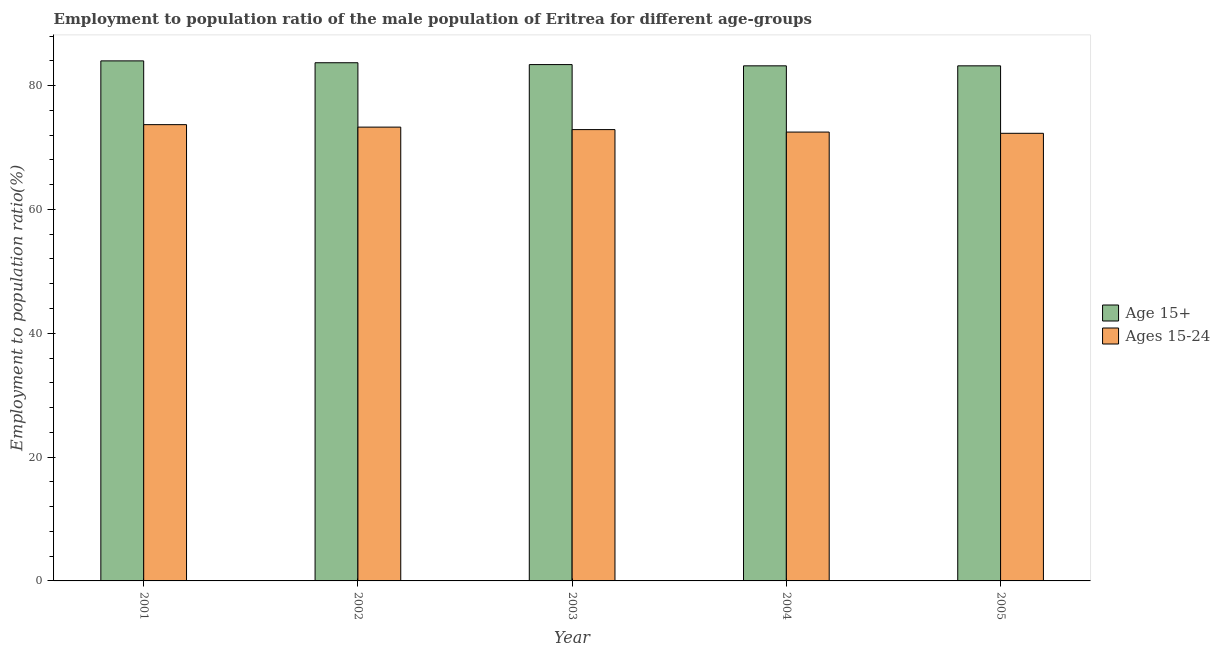How many groups of bars are there?
Your answer should be compact. 5. How many bars are there on the 5th tick from the right?
Your response must be concise. 2. What is the employment to population ratio(age 15-24) in 2002?
Provide a succinct answer. 73.3. Across all years, what is the maximum employment to population ratio(age 15-24)?
Provide a short and direct response. 73.7. Across all years, what is the minimum employment to population ratio(age 15-24)?
Ensure brevity in your answer.  72.3. In which year was the employment to population ratio(age 15+) maximum?
Your response must be concise. 2001. What is the total employment to population ratio(age 15-24) in the graph?
Your answer should be very brief. 364.7. What is the difference between the employment to population ratio(age 15+) in 2002 and that in 2005?
Ensure brevity in your answer.  0.5. What is the difference between the employment to population ratio(age 15-24) in 2001 and the employment to population ratio(age 15+) in 2002?
Offer a terse response. 0.4. What is the average employment to population ratio(age 15-24) per year?
Provide a succinct answer. 72.94. In how many years, is the employment to population ratio(age 15+) greater than 68 %?
Ensure brevity in your answer.  5. What is the ratio of the employment to population ratio(age 15-24) in 2001 to that in 2005?
Ensure brevity in your answer.  1.02. Is the difference between the employment to population ratio(age 15-24) in 2002 and 2003 greater than the difference between the employment to population ratio(age 15+) in 2002 and 2003?
Your answer should be compact. No. What is the difference between the highest and the second highest employment to population ratio(age 15+)?
Ensure brevity in your answer.  0.3. What is the difference between the highest and the lowest employment to population ratio(age 15+)?
Your response must be concise. 0.8. In how many years, is the employment to population ratio(age 15-24) greater than the average employment to population ratio(age 15-24) taken over all years?
Your response must be concise. 2. What does the 2nd bar from the left in 2002 represents?
Provide a short and direct response. Ages 15-24. What does the 1st bar from the right in 2004 represents?
Offer a terse response. Ages 15-24. How many bars are there?
Keep it short and to the point. 10. Are all the bars in the graph horizontal?
Keep it short and to the point. No. How many years are there in the graph?
Your response must be concise. 5. Are the values on the major ticks of Y-axis written in scientific E-notation?
Offer a terse response. No. Does the graph contain any zero values?
Your answer should be compact. No. Does the graph contain grids?
Offer a terse response. No. Where does the legend appear in the graph?
Offer a very short reply. Center right. What is the title of the graph?
Make the answer very short. Employment to population ratio of the male population of Eritrea for different age-groups. Does "State government" appear as one of the legend labels in the graph?
Provide a short and direct response. No. What is the label or title of the X-axis?
Ensure brevity in your answer.  Year. What is the Employment to population ratio(%) in Age 15+ in 2001?
Provide a short and direct response. 84. What is the Employment to population ratio(%) of Ages 15-24 in 2001?
Offer a terse response. 73.7. What is the Employment to population ratio(%) of Age 15+ in 2002?
Give a very brief answer. 83.7. What is the Employment to population ratio(%) in Ages 15-24 in 2002?
Offer a terse response. 73.3. What is the Employment to population ratio(%) of Age 15+ in 2003?
Your answer should be very brief. 83.4. What is the Employment to population ratio(%) in Ages 15-24 in 2003?
Your answer should be very brief. 72.9. What is the Employment to population ratio(%) of Age 15+ in 2004?
Offer a terse response. 83.2. What is the Employment to population ratio(%) of Ages 15-24 in 2004?
Offer a terse response. 72.5. What is the Employment to population ratio(%) in Age 15+ in 2005?
Make the answer very short. 83.2. What is the Employment to population ratio(%) in Ages 15-24 in 2005?
Provide a succinct answer. 72.3. Across all years, what is the maximum Employment to population ratio(%) of Ages 15-24?
Your answer should be very brief. 73.7. Across all years, what is the minimum Employment to population ratio(%) in Age 15+?
Offer a terse response. 83.2. Across all years, what is the minimum Employment to population ratio(%) of Ages 15-24?
Provide a short and direct response. 72.3. What is the total Employment to population ratio(%) in Age 15+ in the graph?
Provide a short and direct response. 417.5. What is the total Employment to population ratio(%) in Ages 15-24 in the graph?
Provide a short and direct response. 364.7. What is the difference between the Employment to population ratio(%) in Ages 15-24 in 2001 and that in 2002?
Your answer should be very brief. 0.4. What is the difference between the Employment to population ratio(%) in Age 15+ in 2001 and that in 2003?
Make the answer very short. 0.6. What is the difference between the Employment to population ratio(%) in Age 15+ in 2001 and that in 2004?
Provide a succinct answer. 0.8. What is the difference between the Employment to population ratio(%) of Ages 15-24 in 2001 and that in 2004?
Offer a very short reply. 1.2. What is the difference between the Employment to population ratio(%) in Age 15+ in 2002 and that in 2003?
Give a very brief answer. 0.3. What is the difference between the Employment to population ratio(%) in Ages 15-24 in 2002 and that in 2003?
Offer a terse response. 0.4. What is the difference between the Employment to population ratio(%) of Age 15+ in 2002 and that in 2004?
Your response must be concise. 0.5. What is the difference between the Employment to population ratio(%) of Ages 15-24 in 2002 and that in 2005?
Make the answer very short. 1. What is the difference between the Employment to population ratio(%) of Age 15+ in 2003 and that in 2005?
Your answer should be compact. 0.2. What is the difference between the Employment to population ratio(%) in Ages 15-24 in 2003 and that in 2005?
Your answer should be very brief. 0.6. What is the difference between the Employment to population ratio(%) of Age 15+ in 2001 and the Employment to population ratio(%) of Ages 15-24 in 2004?
Provide a short and direct response. 11.5. What is the difference between the Employment to population ratio(%) of Age 15+ in 2001 and the Employment to population ratio(%) of Ages 15-24 in 2005?
Offer a terse response. 11.7. What is the difference between the Employment to population ratio(%) in Age 15+ in 2002 and the Employment to population ratio(%) in Ages 15-24 in 2003?
Offer a terse response. 10.8. What is the difference between the Employment to population ratio(%) of Age 15+ in 2002 and the Employment to population ratio(%) of Ages 15-24 in 2004?
Ensure brevity in your answer.  11.2. What is the difference between the Employment to population ratio(%) of Age 15+ in 2003 and the Employment to population ratio(%) of Ages 15-24 in 2005?
Give a very brief answer. 11.1. What is the difference between the Employment to population ratio(%) of Age 15+ in 2004 and the Employment to population ratio(%) of Ages 15-24 in 2005?
Your response must be concise. 10.9. What is the average Employment to population ratio(%) of Age 15+ per year?
Provide a short and direct response. 83.5. What is the average Employment to population ratio(%) of Ages 15-24 per year?
Provide a succinct answer. 72.94. In the year 2004, what is the difference between the Employment to population ratio(%) in Age 15+ and Employment to population ratio(%) in Ages 15-24?
Your answer should be very brief. 10.7. What is the ratio of the Employment to population ratio(%) in Age 15+ in 2001 to that in 2002?
Ensure brevity in your answer.  1. What is the ratio of the Employment to population ratio(%) of Ages 15-24 in 2001 to that in 2002?
Provide a short and direct response. 1.01. What is the ratio of the Employment to population ratio(%) of Age 15+ in 2001 to that in 2004?
Your answer should be compact. 1.01. What is the ratio of the Employment to population ratio(%) in Ages 15-24 in 2001 to that in 2004?
Your answer should be very brief. 1.02. What is the ratio of the Employment to population ratio(%) in Age 15+ in 2001 to that in 2005?
Provide a succinct answer. 1.01. What is the ratio of the Employment to population ratio(%) of Ages 15-24 in 2001 to that in 2005?
Provide a succinct answer. 1.02. What is the ratio of the Employment to population ratio(%) of Ages 15-24 in 2002 to that in 2003?
Provide a short and direct response. 1.01. What is the ratio of the Employment to population ratio(%) in Ages 15-24 in 2002 to that in 2004?
Make the answer very short. 1.01. What is the ratio of the Employment to population ratio(%) in Age 15+ in 2002 to that in 2005?
Make the answer very short. 1.01. What is the ratio of the Employment to population ratio(%) in Ages 15-24 in 2002 to that in 2005?
Give a very brief answer. 1.01. What is the ratio of the Employment to population ratio(%) in Ages 15-24 in 2003 to that in 2004?
Ensure brevity in your answer.  1.01. What is the ratio of the Employment to population ratio(%) of Age 15+ in 2003 to that in 2005?
Give a very brief answer. 1. What is the ratio of the Employment to population ratio(%) of Ages 15-24 in 2003 to that in 2005?
Your answer should be very brief. 1.01. What is the ratio of the Employment to population ratio(%) in Age 15+ in 2004 to that in 2005?
Your answer should be compact. 1. What is the ratio of the Employment to population ratio(%) of Ages 15-24 in 2004 to that in 2005?
Give a very brief answer. 1. What is the difference between the highest and the second highest Employment to population ratio(%) in Age 15+?
Provide a short and direct response. 0.3. What is the difference between the highest and the second highest Employment to population ratio(%) in Ages 15-24?
Keep it short and to the point. 0.4. 